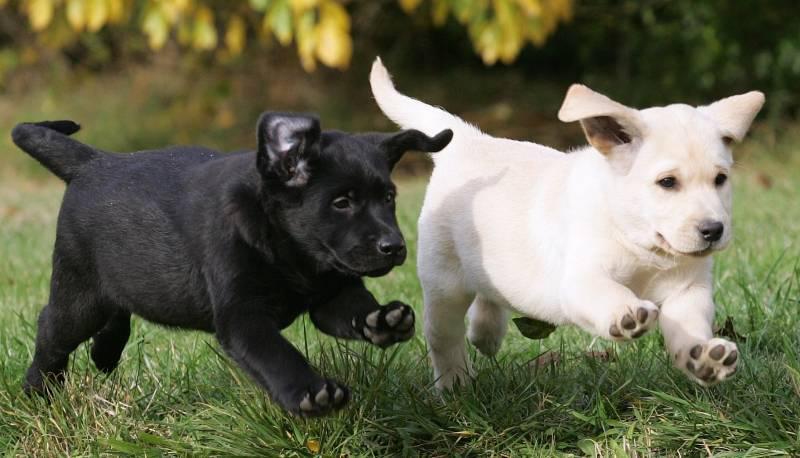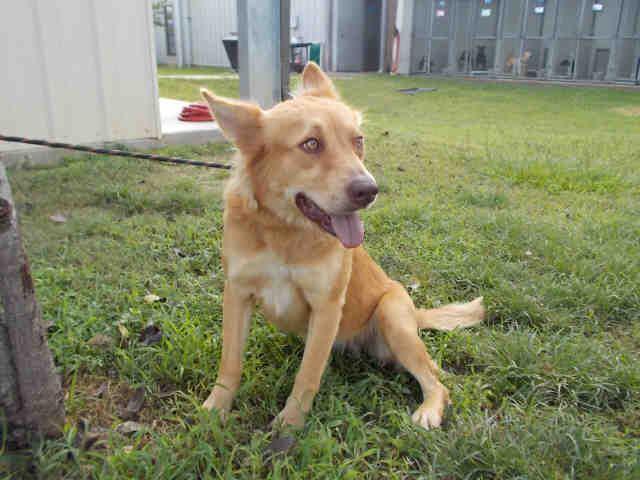The first image is the image on the left, the second image is the image on the right. Considering the images on both sides, is "The right image contains two dogs." valid? Answer yes or no. No. The first image is the image on the left, the second image is the image on the right. For the images shown, is this caption "There are four dogs in total." true? Answer yes or no. No. 